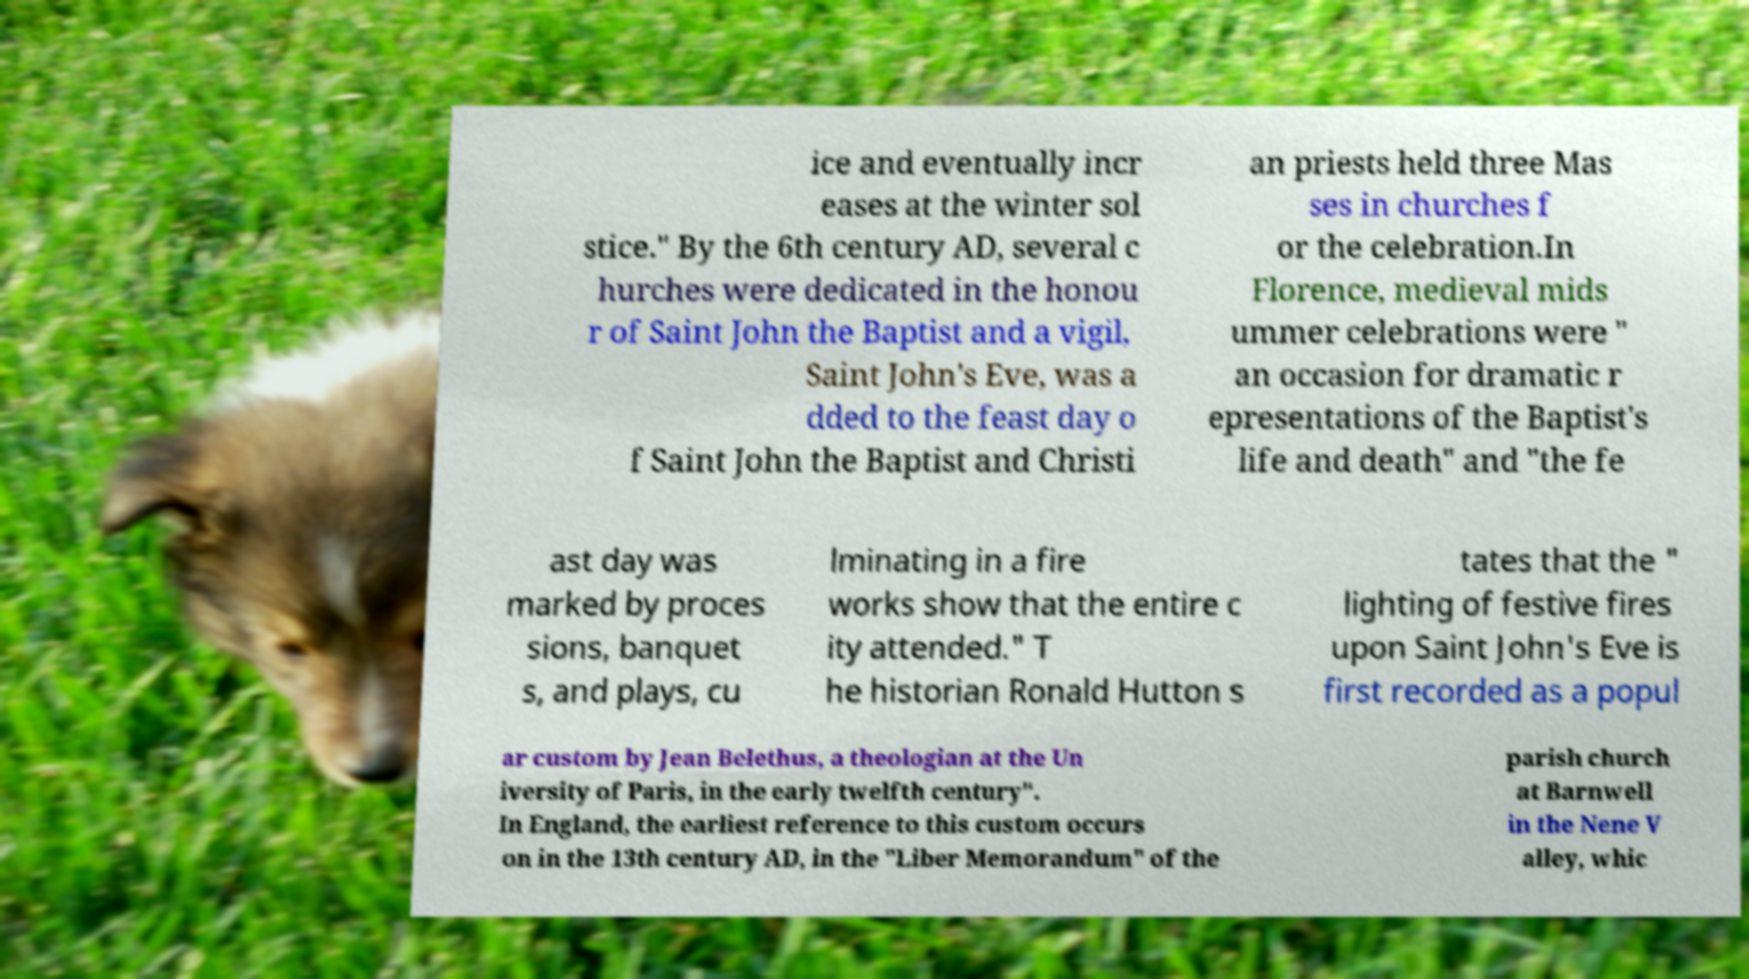For documentation purposes, I need the text within this image transcribed. Could you provide that? ice and eventually incr eases at the winter sol stice." By the 6th century AD, several c hurches were dedicated in the honou r of Saint John the Baptist and a vigil, Saint John's Eve, was a dded to the feast day o f Saint John the Baptist and Christi an priests held three Mas ses in churches f or the celebration.In Florence, medieval mids ummer celebrations were " an occasion for dramatic r epresentations of the Baptist's life and death" and "the fe ast day was marked by proces sions, banquet s, and plays, cu lminating in a fire works show that the entire c ity attended." T he historian Ronald Hutton s tates that the " lighting of festive fires upon Saint John's Eve is first recorded as a popul ar custom by Jean Belethus, a theologian at the Un iversity of Paris, in the early twelfth century". In England, the earliest reference to this custom occurs on in the 13th century AD, in the "Liber Memorandum" of the parish church at Barnwell in the Nene V alley, whic 